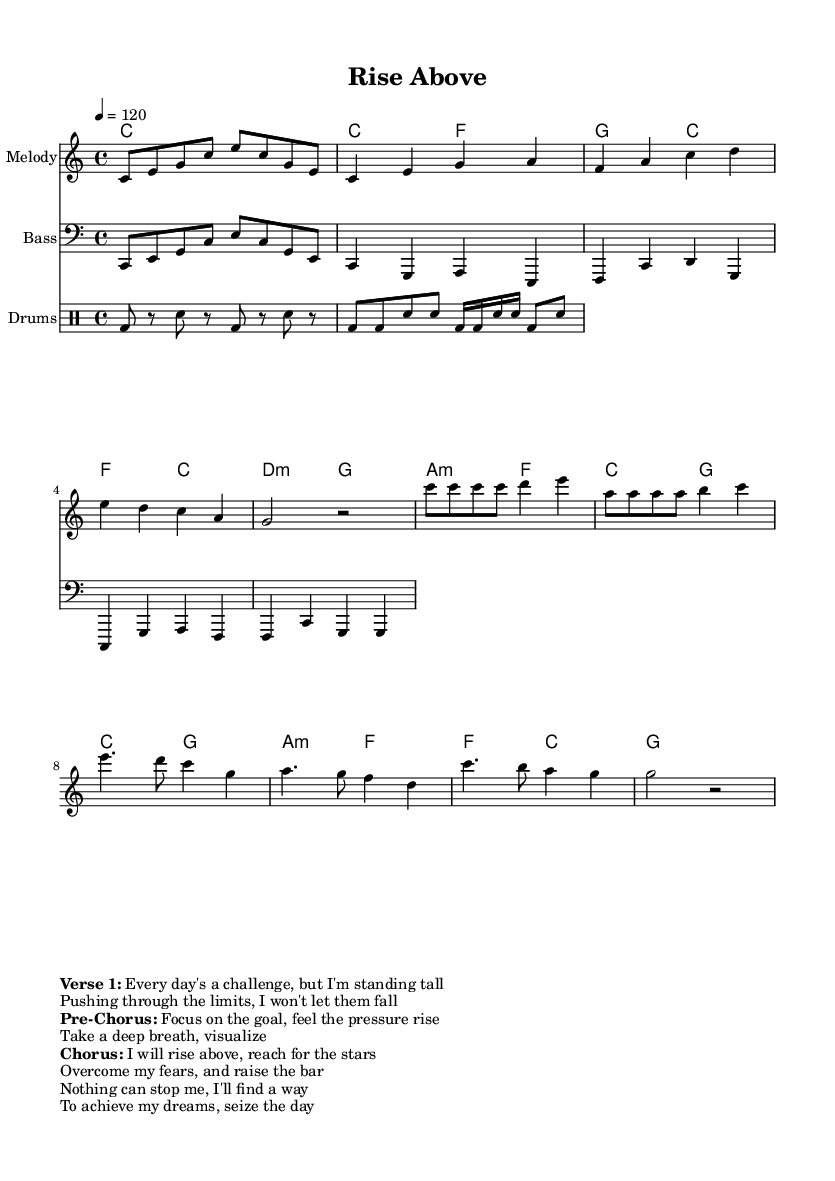What is the key signature of this music? The key signature is indicated at the beginning of the score. It shows one flat in the key signature, which corresponds to the key of C major.
Answer: C major What is the time signature of this piece? The time signature is represented as "4/4" at the beginning of the score, indicating that there are four beats in a measure and the quarter note gets one beat.
Answer: 4/4 What is the tempo marking for this composition? The tempo is marked as "4 = 120," which indicates that the quarter note should be played at a speed of 120 beats per minute.
Answer: 120 What chords are used in the chorus? The chords for the chorus section can be derived from the harmonic part during the chorus. It corresponds to C, A minor, F, and G chords.
Answer: C, A minor, F, G How many measures are in the verse of the piece? The verse section features a total of four measures, as denoted by the bars in the melody line and harmonic line.
Answer: 4 What is the lyrical theme of the song as indicated in the sheet music? The lyrics suggest a theme of perseverance and aspiration, emphasizing overcoming challenges and achieving one's dreams through focus and effort.
Answer: Overcoming challenges and achieving dreams 